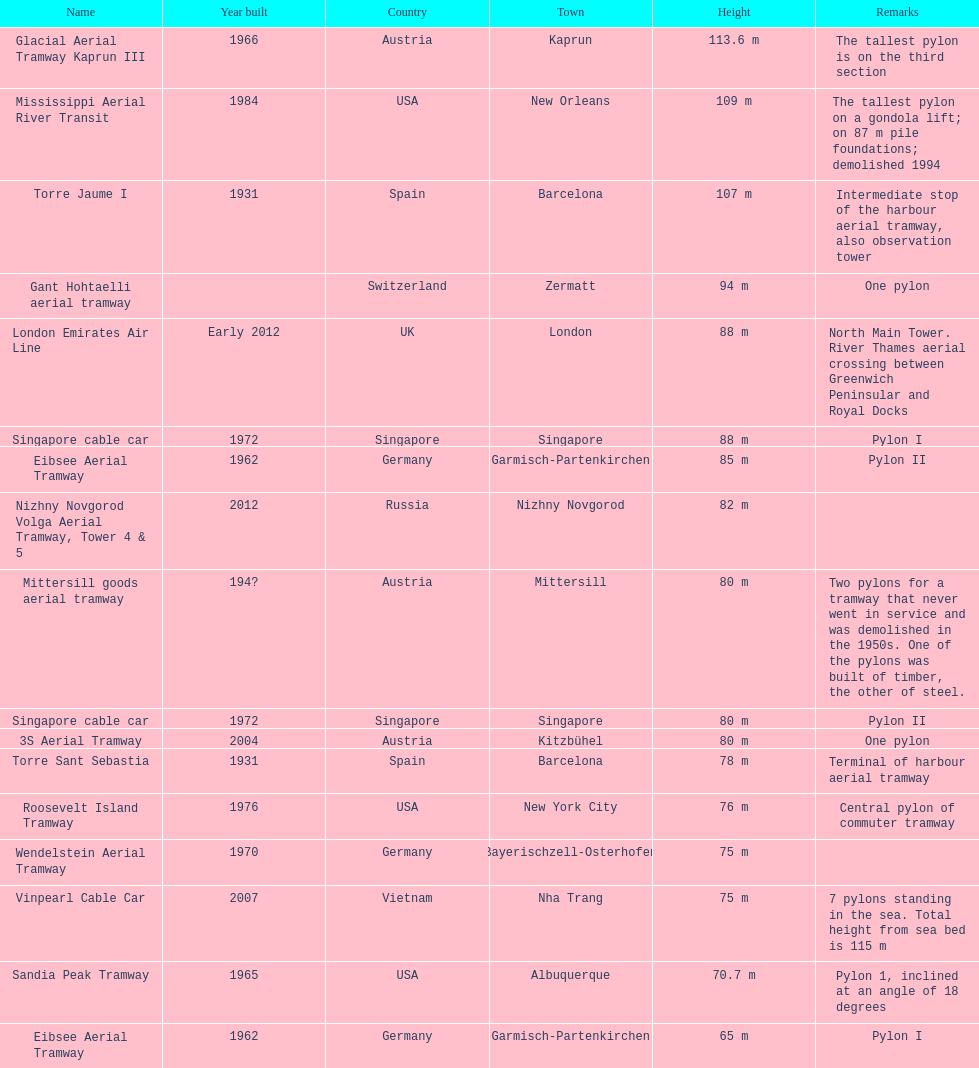What is the total number of tallest pylons in austria? 3. 